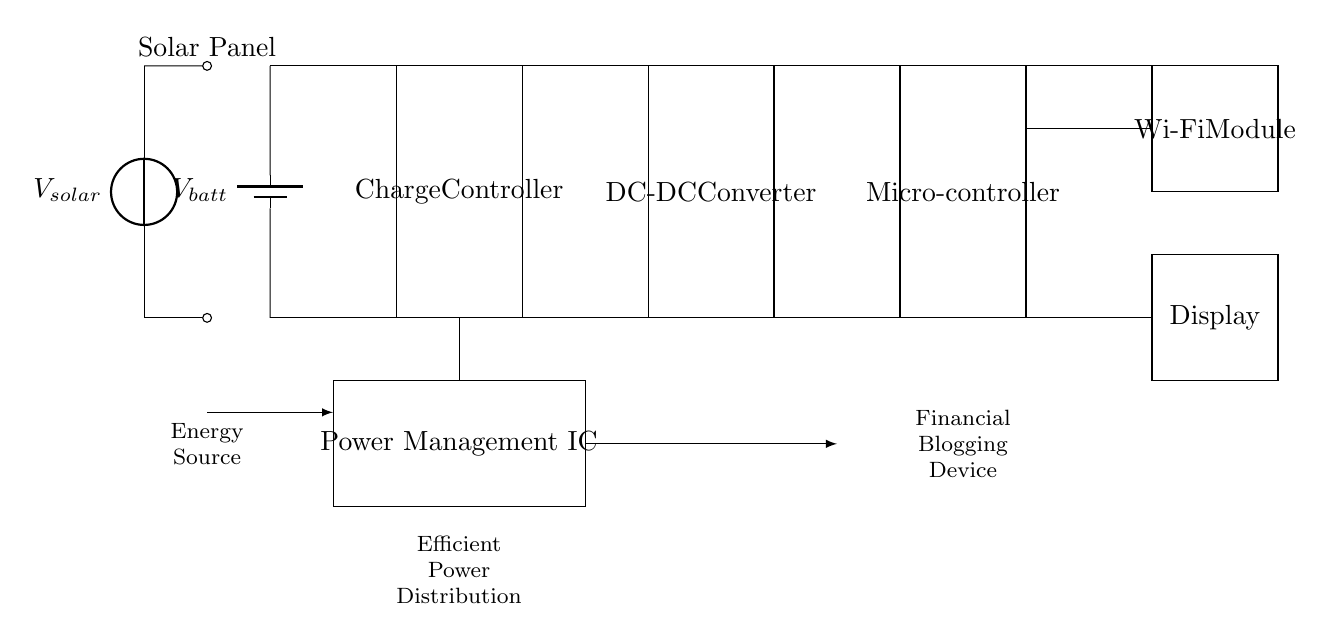What is the main energy source for this circuit? The main energy source is the solar panel, which is indicated in the circuit as the first component providing voltage.
Answer: Solar Panel What component is responsible for managing the battery charge? The charge controller's purpose is to regulate the charging of the battery. It is shown connected directly to the battery and solar panel in the circuit.
Answer: Charge Controller How many voltage sources are present in this circuit? There are two voltage sources, one from the solar panel and one indicated by the battery. Each source is clearly labeled in the circuit diagram.
Answer: Two What is the role of the DC-DC converter in the circuit? The DC-DC converter regulates and converts the voltage levels to be suitable for use in the microcontroller and other components. Its position in the circuit shows it receives input from the charge controller and feeds power to the microcontroller.
Answer: Voltage regulation Which component provides power to the display? The display receives power through connections originating from the microcontroller, indicating it draws power from the circuit to function. The direct line from the microcontroller shows this relationship.
Answer: Microcontroller What does the Power Management IC do in this circuit? The Power Management IC ensures efficient distribution of the power received from the battery and solar panel to various components like the microcontroller and Wi-Fi module, as noted by its central position and connection to the other components.
Answer: Efficient power distribution Why is the output from the charge controller connected to the DC-DC converter? This connection allows the voltage coming from the charge controller, which is higher or fluctuating, to be converted to the appropriate level required by the microcontroller and other downstream components for effective operation.
Answer: Voltage adjustment 